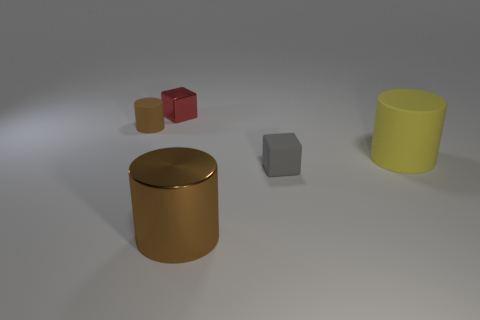Are there any other tiny rubber blocks of the same color as the rubber block?
Your response must be concise. No. Are there any tiny gray matte objects to the left of the metal object in front of the yellow thing?
Ensure brevity in your answer.  No. Are there any other tiny things that have the same material as the gray object?
Your answer should be very brief. Yes. The brown cylinder that is in front of the tiny cube to the right of the red metallic block is made of what material?
Ensure brevity in your answer.  Metal. The object that is right of the big brown cylinder and to the left of the big yellow object is made of what material?
Provide a succinct answer. Rubber. Are there the same number of tiny cylinders to the right of the small cylinder and red metallic objects?
Make the answer very short. No. How many small gray matte objects have the same shape as the brown matte object?
Ensure brevity in your answer.  0. What is the size of the brown thing behind the small block that is right of the large object that is in front of the yellow thing?
Ensure brevity in your answer.  Small. Are the large object on the left side of the yellow object and the gray cube made of the same material?
Give a very brief answer. No. Are there an equal number of small brown objects that are in front of the gray matte thing and small red blocks on the right side of the large matte object?
Your answer should be very brief. Yes. 